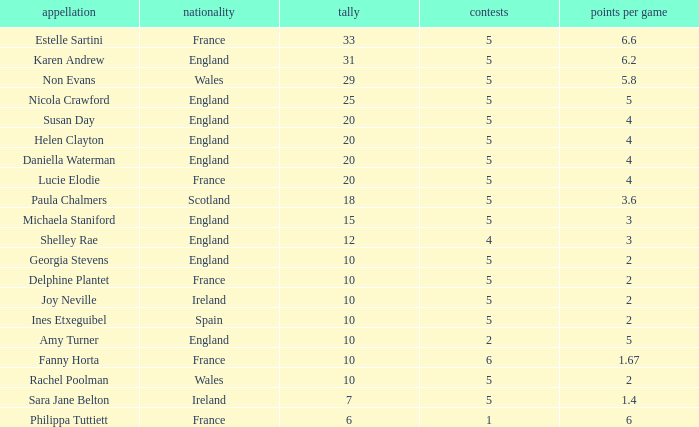Could you parse the entire table? {'header': ['appellation', 'nationality', 'tally', 'contests', 'points per game'], 'rows': [['Estelle Sartini', 'France', '33', '5', '6.6'], ['Karen Andrew', 'England', '31', '5', '6.2'], ['Non Evans', 'Wales', '29', '5', '5.8'], ['Nicola Crawford', 'England', '25', '5', '5'], ['Susan Day', 'England', '20', '5', '4'], ['Helen Clayton', 'England', '20', '5', '4'], ['Daniella Waterman', 'England', '20', '5', '4'], ['Lucie Elodie', 'France', '20', '5', '4'], ['Paula Chalmers', 'Scotland', '18', '5', '3.6'], ['Michaela Staniford', 'England', '15', '5', '3'], ['Shelley Rae', 'England', '12', '4', '3'], ['Georgia Stevens', 'England', '10', '5', '2'], ['Delphine Plantet', 'France', '10', '5', '2'], ['Joy Neville', 'Ireland', '10', '5', '2'], ['Ines Etxeguibel', 'Spain', '10', '5', '2'], ['Amy Turner', 'England', '10', '2', '5'], ['Fanny Horta', 'France', '10', '6', '1.67'], ['Rachel Poolman', 'Wales', '10', '5', '2'], ['Sara Jane Belton', 'Ireland', '7', '5', '1.4'], ['Philippa Tuttiett', 'France', '6', '1', '6']]} Can you tell me the lowest Pts/game that has the Name of philippa tuttiett, and the Points larger then 6? None. 